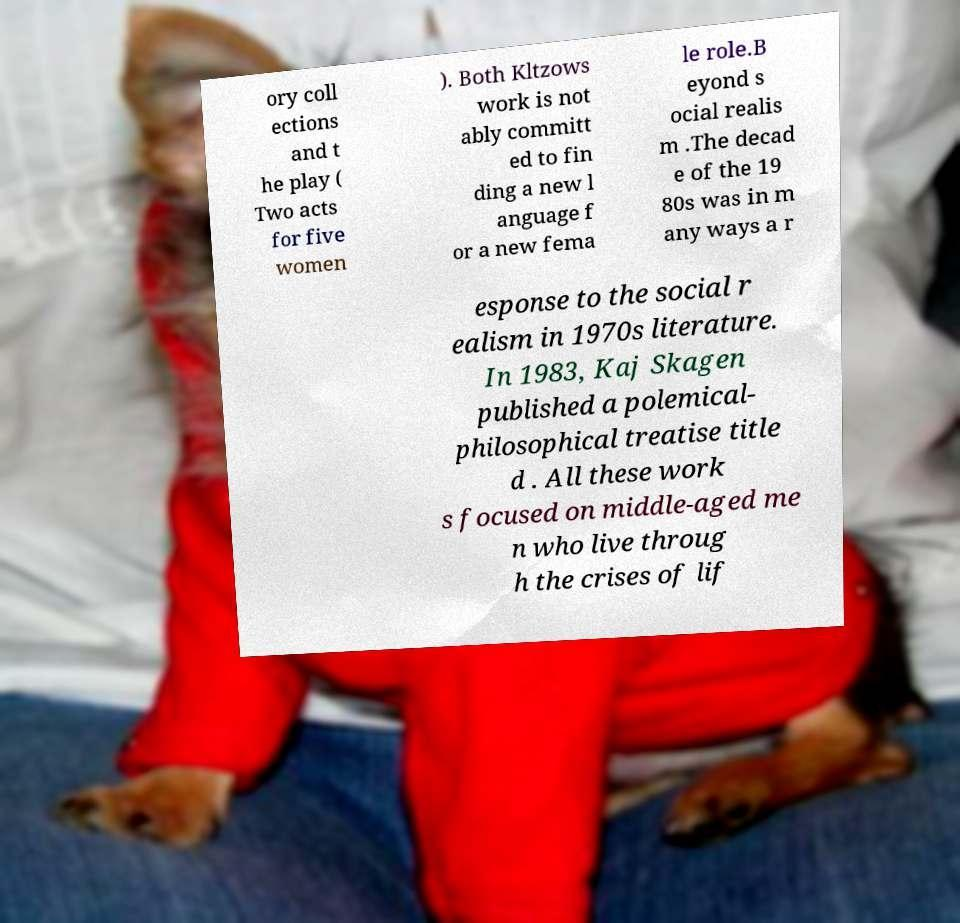Can you read and provide the text displayed in the image?This photo seems to have some interesting text. Can you extract and type it out for me? ory coll ections and t he play ( Two acts for five women ). Both Kltzows work is not ably committ ed to fin ding a new l anguage f or a new fema le role.B eyond s ocial realis m .The decad e of the 19 80s was in m any ways a r esponse to the social r ealism in 1970s literature. In 1983, Kaj Skagen published a polemical- philosophical treatise title d . All these work s focused on middle-aged me n who live throug h the crises of lif 